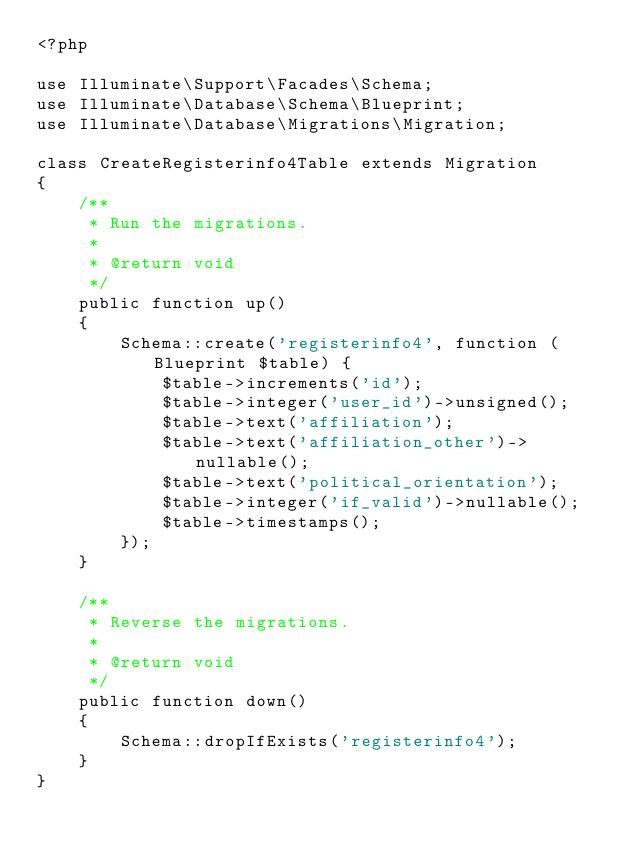<code> <loc_0><loc_0><loc_500><loc_500><_PHP_><?php

use Illuminate\Support\Facades\Schema;
use Illuminate\Database\Schema\Blueprint;
use Illuminate\Database\Migrations\Migration;

class CreateRegisterinfo4Table extends Migration
{
    /**
     * Run the migrations.
     *
     * @return void
     */
    public function up()
    {
        Schema::create('registerinfo4', function (Blueprint $table) {
            $table->increments('id');
            $table->integer('user_id')->unsigned();
            $table->text('affiliation');
            $table->text('affiliation_other')->nullable();
            $table->text('political_orientation');
            $table->integer('if_valid')->nullable();
            $table->timestamps();
        });
    }

    /**
     * Reverse the migrations.
     *
     * @return void
     */
    public function down()
    {
        Schema::dropIfExists('registerinfo4');
    }
}
</code> 